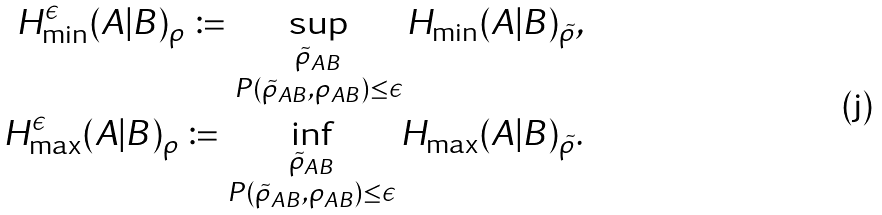Convert formula to latex. <formula><loc_0><loc_0><loc_500><loc_500>H _ { \min } ^ { \epsilon } ( A | B ) _ { \rho } \coloneqq \sup _ { \substack { \tilde { \rho } _ { A B } \\ P ( \tilde { \rho } _ { A B } , \rho _ { A B } ) \leq \epsilon } } H _ { \min } ( A | B ) _ { \tilde { \rho } } , \\ H _ { \max } ^ { \epsilon } ( A | B ) _ { \rho } \coloneqq \inf _ { \substack { \tilde { \rho } _ { A B } \\ P ( \tilde { \rho } _ { A B } , \rho _ { A B } ) \leq \epsilon } } H _ { \max } ( A | B ) _ { \tilde { \rho } } .</formula> 